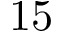Convert formula to latex. <formula><loc_0><loc_0><loc_500><loc_500>1 5</formula> 